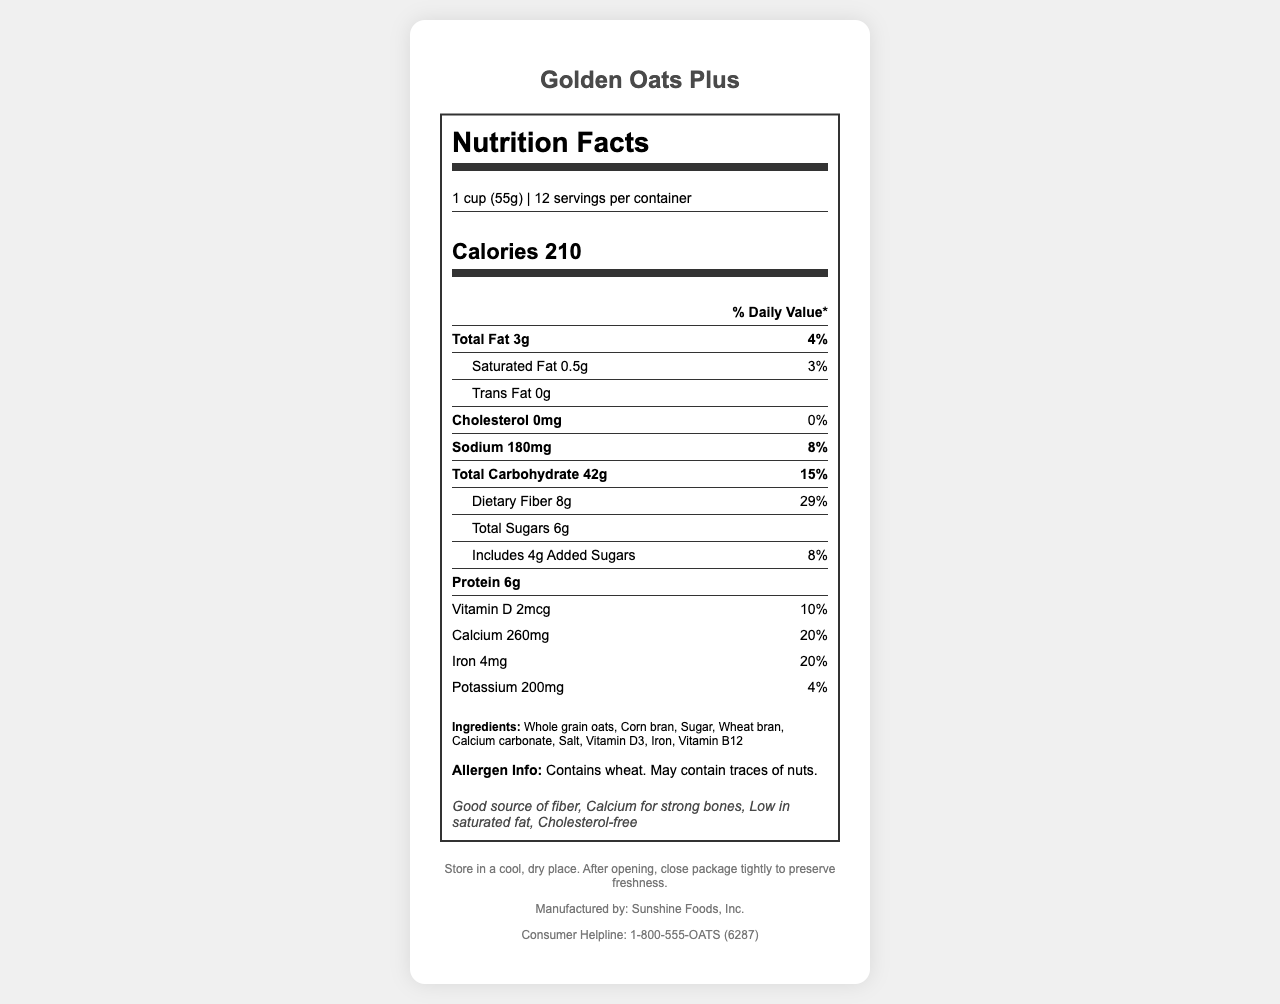what is the serving size? The serving size is clearly specified in the Serving Info section of the nutrition label.
Answer: 1 cup (55g) how many calories are there per serving? The number of calories per serving is prominently displayed in the Calorie Info section.
Answer: 210 what percentage of the daily value is the dietary fiber? The daily value percentage for dietary fiber is found alongside its amount in the Nutrient Row.
Answer: 29% how much calcium is in one serving? The amount of calcium per serving is listed in the Vitamin Row, next to Calcium.
Answer: 260mg what is the main ingredient? The main ingredient is typically listed first in the Ingredients section.
Answer: Whole grain oats how many grams of total carbohydrates are there per serving? The total carbohydrates amount is listed in the Nutrient Row under Total Carbohydrate.
Answer: 42g what is the daily value percentage for sodium? A. 4% B. 5% C. 6% D. 7% E. 8% The daily value percentage for sodium is 8%, as seen in the Nutrient Row under Sodium.
Answer: E. 8% how many grams of added sugars are in one serving? A. 2g B. 3g C. 4g D. 5g The amount of added sugars is listed under Total Sugars as "Includes 4g Added Sugars."
Answer: C. 4g does this cereal contain cholesterol? The document specifies 0mg of cholesterol, indicating that it contains no cholesterol.
Answer: No what are the health claims made by the product? The health claims are listed in the Health Claims section.
Answer: Good source of fiber, Calcium for strong bones, Low in saturated fat, Cholesterol-free describe the contents and main idea of the document. The document's main idea is to inform consumers about the nutritional value, ingredients, and health benefits of Golden Oats Plus cereal.
Answer: The document is a nutrition facts label for a breakfast cereal named Golden Oats Plus. It provides detailed nutritional information, including serving size, caloric content, and daily value percentages of various nutrients. The label also lists ingredients, allergen information, health claims, storage instructions, manufacturer details, and a consumer helpline. what is the consumer helpline number? The consumer helpline number is listed in the Footer section.
Answer: 1-800-555-OATS (6287) who is the manufacturer of Golden Oats Plus? The manufacturer's information is found in the Footer section.
Answer: Sunshine Foods, Inc. what is the main source of calcium in the product? The label only lists the ingredients, and although calcium carbonate is mentioned, it does not specify if it is the main source of calcium.
Answer: Not enough information is the breakfast cereal suitable for people with a nut allergy? The allergen information indicates that the product may contain traces of nuts, making it unsuitable for people with a nut allergy.
Answer: No 